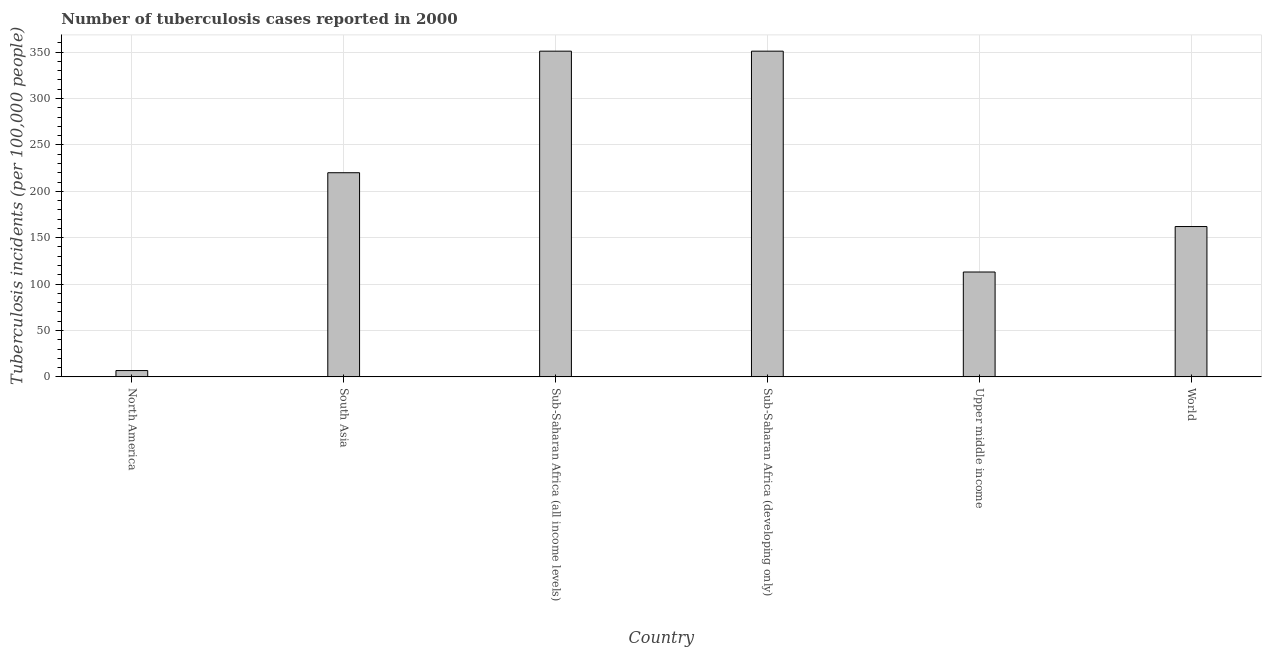What is the title of the graph?
Your answer should be very brief. Number of tuberculosis cases reported in 2000. What is the label or title of the Y-axis?
Keep it short and to the point. Tuberculosis incidents (per 100,0 people). What is the number of tuberculosis incidents in South Asia?
Give a very brief answer. 220. Across all countries, what is the maximum number of tuberculosis incidents?
Provide a short and direct response. 351. Across all countries, what is the minimum number of tuberculosis incidents?
Your response must be concise. 6.8. In which country was the number of tuberculosis incidents maximum?
Offer a terse response. Sub-Saharan Africa (all income levels). What is the sum of the number of tuberculosis incidents?
Provide a short and direct response. 1203.8. What is the difference between the number of tuberculosis incidents in Sub-Saharan Africa (all income levels) and World?
Provide a short and direct response. 189. What is the average number of tuberculosis incidents per country?
Keep it short and to the point. 200.63. What is the median number of tuberculosis incidents?
Your answer should be compact. 191. In how many countries, is the number of tuberculosis incidents greater than 70 ?
Provide a short and direct response. 5. What is the ratio of the number of tuberculosis incidents in North America to that in Sub-Saharan Africa (developing only)?
Keep it short and to the point. 0.02. Is the number of tuberculosis incidents in Sub-Saharan Africa (all income levels) less than that in Sub-Saharan Africa (developing only)?
Keep it short and to the point. No. What is the difference between the highest and the second highest number of tuberculosis incidents?
Provide a succinct answer. 0. Is the sum of the number of tuberculosis incidents in Sub-Saharan Africa (developing only) and World greater than the maximum number of tuberculosis incidents across all countries?
Ensure brevity in your answer.  Yes. What is the difference between the highest and the lowest number of tuberculosis incidents?
Your answer should be very brief. 344.2. In how many countries, is the number of tuberculosis incidents greater than the average number of tuberculosis incidents taken over all countries?
Provide a short and direct response. 3. How many bars are there?
Your answer should be very brief. 6. What is the Tuberculosis incidents (per 100,000 people) of South Asia?
Give a very brief answer. 220. What is the Tuberculosis incidents (per 100,000 people) of Sub-Saharan Africa (all income levels)?
Your response must be concise. 351. What is the Tuberculosis incidents (per 100,000 people) of Sub-Saharan Africa (developing only)?
Offer a very short reply. 351. What is the Tuberculosis incidents (per 100,000 people) in Upper middle income?
Provide a short and direct response. 113. What is the Tuberculosis incidents (per 100,000 people) in World?
Your answer should be compact. 162. What is the difference between the Tuberculosis incidents (per 100,000 people) in North America and South Asia?
Provide a succinct answer. -213.2. What is the difference between the Tuberculosis incidents (per 100,000 people) in North America and Sub-Saharan Africa (all income levels)?
Give a very brief answer. -344.2. What is the difference between the Tuberculosis incidents (per 100,000 people) in North America and Sub-Saharan Africa (developing only)?
Keep it short and to the point. -344.2. What is the difference between the Tuberculosis incidents (per 100,000 people) in North America and Upper middle income?
Provide a succinct answer. -106.2. What is the difference between the Tuberculosis incidents (per 100,000 people) in North America and World?
Your answer should be compact. -155.2. What is the difference between the Tuberculosis incidents (per 100,000 people) in South Asia and Sub-Saharan Africa (all income levels)?
Your response must be concise. -131. What is the difference between the Tuberculosis incidents (per 100,000 people) in South Asia and Sub-Saharan Africa (developing only)?
Your answer should be very brief. -131. What is the difference between the Tuberculosis incidents (per 100,000 people) in South Asia and Upper middle income?
Give a very brief answer. 107. What is the difference between the Tuberculosis incidents (per 100,000 people) in South Asia and World?
Offer a very short reply. 58. What is the difference between the Tuberculosis incidents (per 100,000 people) in Sub-Saharan Africa (all income levels) and Sub-Saharan Africa (developing only)?
Provide a short and direct response. 0. What is the difference between the Tuberculosis incidents (per 100,000 people) in Sub-Saharan Africa (all income levels) and Upper middle income?
Provide a short and direct response. 238. What is the difference between the Tuberculosis incidents (per 100,000 people) in Sub-Saharan Africa (all income levels) and World?
Keep it short and to the point. 189. What is the difference between the Tuberculosis incidents (per 100,000 people) in Sub-Saharan Africa (developing only) and Upper middle income?
Keep it short and to the point. 238. What is the difference between the Tuberculosis incidents (per 100,000 people) in Sub-Saharan Africa (developing only) and World?
Offer a terse response. 189. What is the difference between the Tuberculosis incidents (per 100,000 people) in Upper middle income and World?
Your answer should be very brief. -49. What is the ratio of the Tuberculosis incidents (per 100,000 people) in North America to that in South Asia?
Your response must be concise. 0.03. What is the ratio of the Tuberculosis incidents (per 100,000 people) in North America to that in Sub-Saharan Africa (all income levels)?
Ensure brevity in your answer.  0.02. What is the ratio of the Tuberculosis incidents (per 100,000 people) in North America to that in Sub-Saharan Africa (developing only)?
Make the answer very short. 0.02. What is the ratio of the Tuberculosis incidents (per 100,000 people) in North America to that in Upper middle income?
Provide a short and direct response. 0.06. What is the ratio of the Tuberculosis incidents (per 100,000 people) in North America to that in World?
Your answer should be compact. 0.04. What is the ratio of the Tuberculosis incidents (per 100,000 people) in South Asia to that in Sub-Saharan Africa (all income levels)?
Ensure brevity in your answer.  0.63. What is the ratio of the Tuberculosis incidents (per 100,000 people) in South Asia to that in Sub-Saharan Africa (developing only)?
Provide a short and direct response. 0.63. What is the ratio of the Tuberculosis incidents (per 100,000 people) in South Asia to that in Upper middle income?
Your answer should be very brief. 1.95. What is the ratio of the Tuberculosis incidents (per 100,000 people) in South Asia to that in World?
Offer a terse response. 1.36. What is the ratio of the Tuberculosis incidents (per 100,000 people) in Sub-Saharan Africa (all income levels) to that in Sub-Saharan Africa (developing only)?
Your response must be concise. 1. What is the ratio of the Tuberculosis incidents (per 100,000 people) in Sub-Saharan Africa (all income levels) to that in Upper middle income?
Give a very brief answer. 3.11. What is the ratio of the Tuberculosis incidents (per 100,000 people) in Sub-Saharan Africa (all income levels) to that in World?
Your response must be concise. 2.17. What is the ratio of the Tuberculosis incidents (per 100,000 people) in Sub-Saharan Africa (developing only) to that in Upper middle income?
Offer a very short reply. 3.11. What is the ratio of the Tuberculosis incidents (per 100,000 people) in Sub-Saharan Africa (developing only) to that in World?
Offer a very short reply. 2.17. What is the ratio of the Tuberculosis incidents (per 100,000 people) in Upper middle income to that in World?
Offer a very short reply. 0.7. 